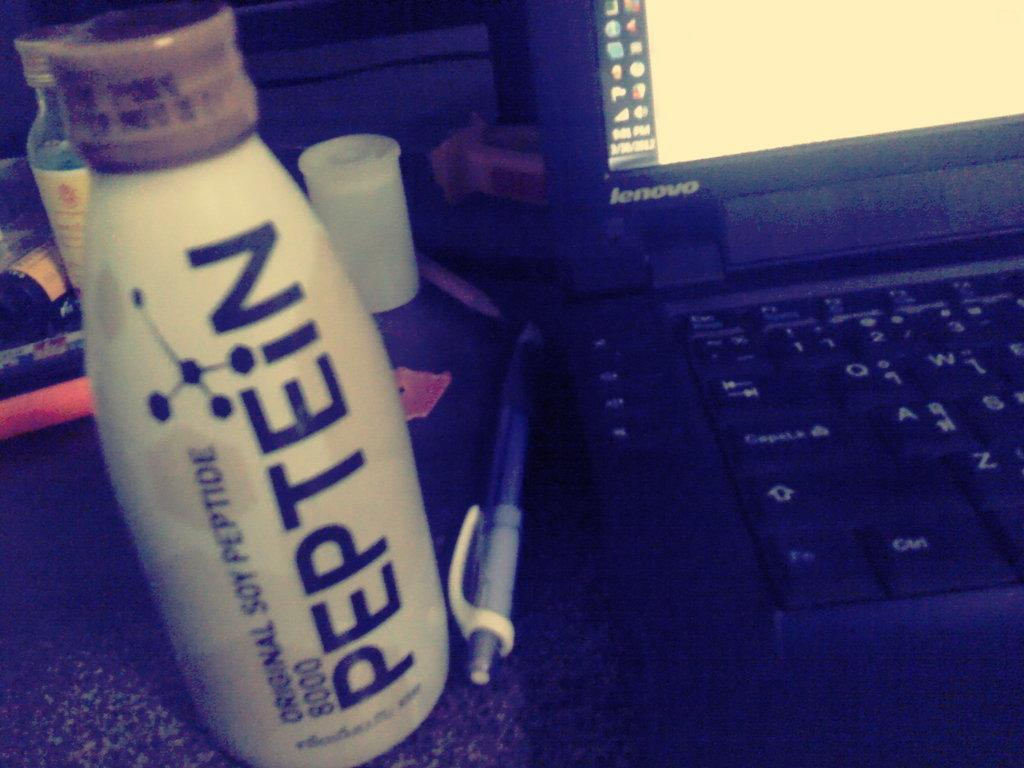Provide a one-sentence caption for the provided image. Bottle named Peptein next to a Lenovo laptop. 